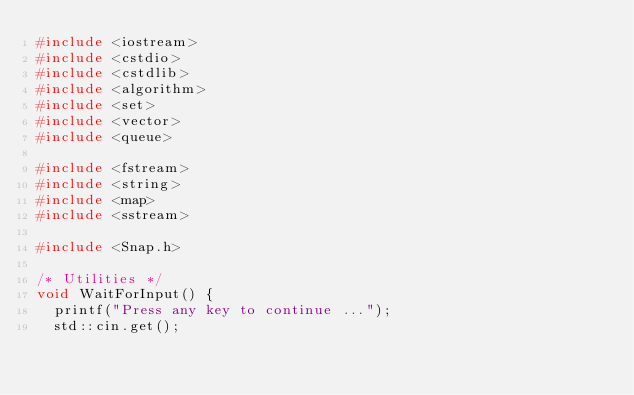<code> <loc_0><loc_0><loc_500><loc_500><_C++_>#include <iostream>
#include <cstdio>
#include <cstdlib>
#include <algorithm>
#include <set>
#include <vector>
#include <queue>

#include <fstream>
#include <string>
#include <map>
#include <sstream>

#include <Snap.h>

/* Utilities */
void WaitForInput() {
	printf("Press any key to continue ...");
	std::cin.get();</code> 